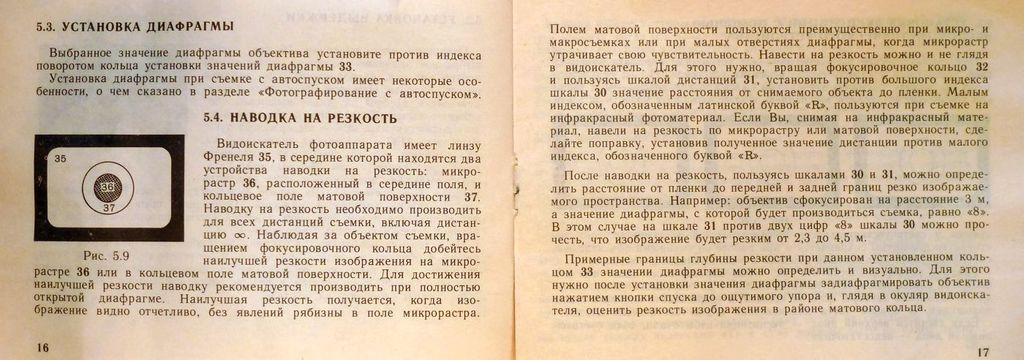How many papers can be seen in the image? There are two papers in the image. What is written on the papers? There is text on the papers. How can the pages of the papers be identified? The papers have page numbers. What type of knee can be seen on the papers in the image? There are no knees present on the papers in the image; they contain text and page numbers. 